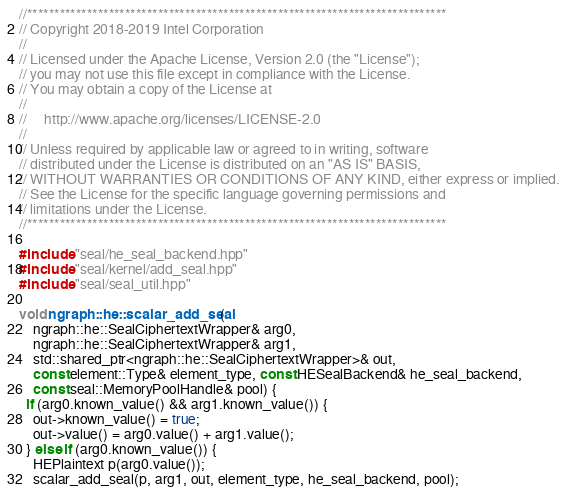Convert code to text. <code><loc_0><loc_0><loc_500><loc_500><_C++_>//*****************************************************************************
// Copyright 2018-2019 Intel Corporation
//
// Licensed under the Apache License, Version 2.0 (the "License");
// you may not use this file except in compliance with the License.
// You may obtain a copy of the License at
//
//     http://www.apache.org/licenses/LICENSE-2.0
//
// Unless required by applicable law or agreed to in writing, software
// distributed under the License is distributed on an "AS IS" BASIS,
// WITHOUT WARRANTIES OR CONDITIONS OF ANY KIND, either express or implied.
// See the License for the specific language governing permissions and
// limitations under the License.
//*****************************************************************************

#include "seal/he_seal_backend.hpp"
#include "seal/kernel/add_seal.hpp"
#include "seal/seal_util.hpp"

void ngraph::he::scalar_add_seal(
    ngraph::he::SealCiphertextWrapper& arg0,
    ngraph::he::SealCiphertextWrapper& arg1,
    std::shared_ptr<ngraph::he::SealCiphertextWrapper>& out,
    const element::Type& element_type, const HESealBackend& he_seal_backend,
    const seal::MemoryPoolHandle& pool) {
  if (arg0.known_value() && arg1.known_value()) {
    out->known_value() = true;
    out->value() = arg0.value() + arg1.value();
  } else if (arg0.known_value()) {
    HEPlaintext p(arg0.value());
    scalar_add_seal(p, arg1, out, element_type, he_seal_backend, pool);</code> 